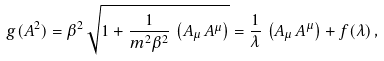<formula> <loc_0><loc_0><loc_500><loc_500>g ( A ^ { 2 } ) = \beta ^ { 2 } \, \sqrt { 1 + \frac { 1 } { m ^ { 2 } \beta ^ { 2 } } \, \left ( A _ { \mu } \, A ^ { \mu } \right ) } = \frac { 1 } { \lambda } \, \left ( A _ { \mu } \, A ^ { \mu } \right ) + f ( \lambda ) \, ,</formula> 